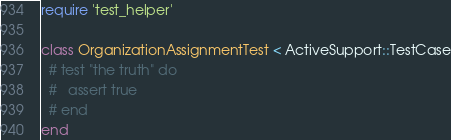<code> <loc_0><loc_0><loc_500><loc_500><_Ruby_>require 'test_helper'

class OrganizationAssignmentTest < ActiveSupport::TestCase
  # test "the truth" do
  #   assert true
  # end
end
</code> 